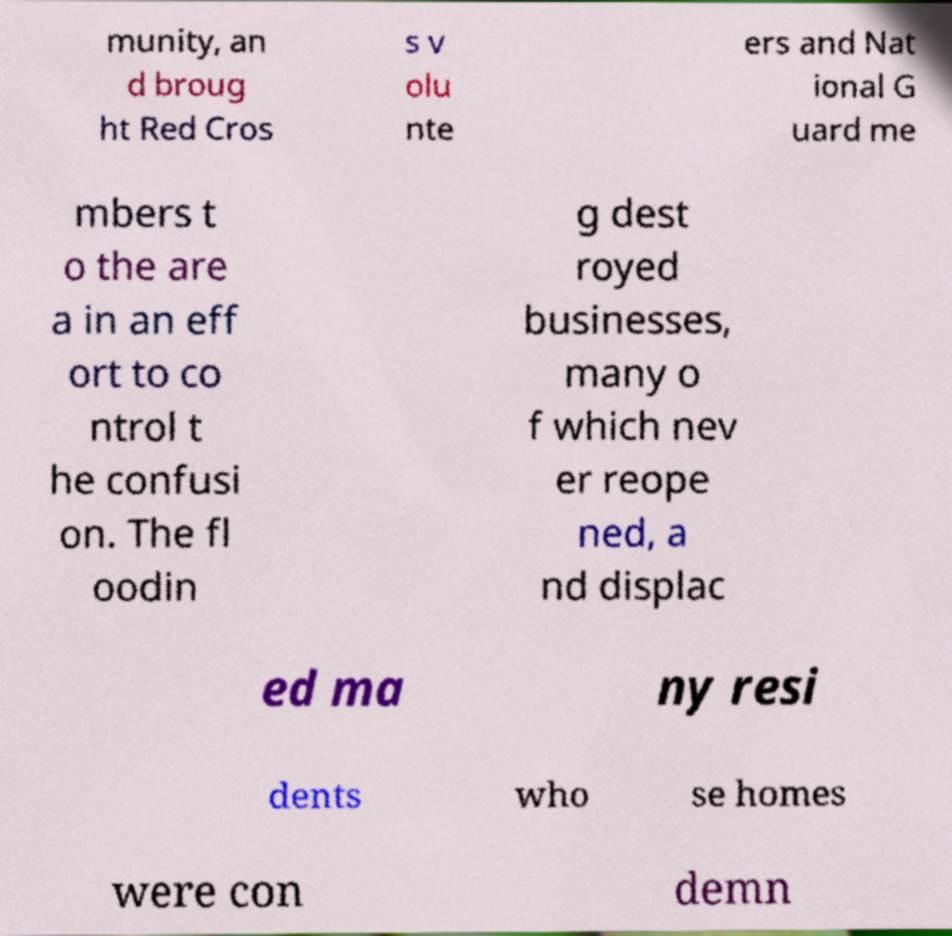I need the written content from this picture converted into text. Can you do that? munity, an d broug ht Red Cros s v olu nte ers and Nat ional G uard me mbers t o the are a in an eff ort to co ntrol t he confusi on. The fl oodin g dest royed businesses, many o f which nev er reope ned, a nd displac ed ma ny resi dents who se homes were con demn 